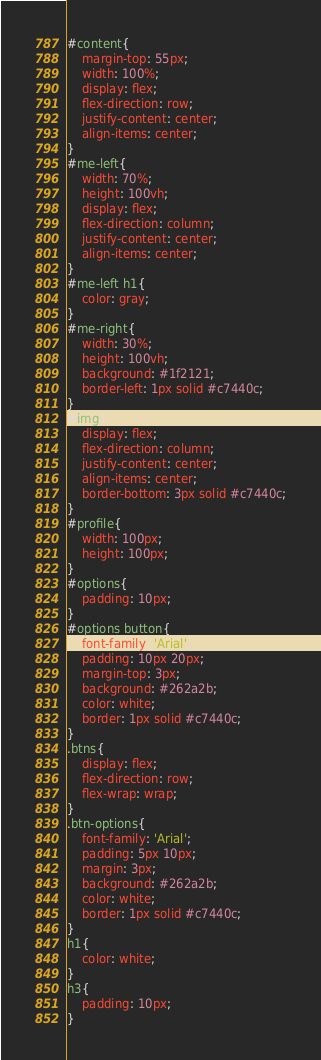<code> <loc_0><loc_0><loc_500><loc_500><_CSS_>#content{
	margin-top: 55px;
	width: 100%;
	display: flex;
	flex-direction: row;
	justify-content: center;
	align-items: center;
}
#me-left{
	width: 70%;
	height: 100vh;	
	display: flex;
	flex-direction: column;
	justify-content: center;
	align-items: center;
}
#me-left h1{
	color: gray;
}
#me-right{
	width: 30%;
	height: 100vh;
	background: #1f2121;
	border-left: 1px solid #c7440c;
}
#img{
	display: flex;
	flex-direction: column;
	justify-content: center;
	align-items: center;
	border-bottom: 3px solid #c7440c;
}
#profile{
	width: 100px;
	height: 100px;
}
#options{
	padding: 10px;
}
#options button{
	font-family: 'Arial';
	padding: 10px 20px;
	margin-top: 3px;
	background: #262a2b;
	color: white;
	border: 1px solid #c7440c;	
}
.btns{
	display: flex;
	flex-direction: row;
	flex-wrap: wrap;
}
.btn-options{	
	font-family: 'Arial';
	padding: 5px 10px;
	margin: 3px;
	background: #262a2b;
	color: white;
	border: 1px solid #c7440c;	
}
h1{
	color: white;
}
h3{
	padding: 10px;
}</code> 